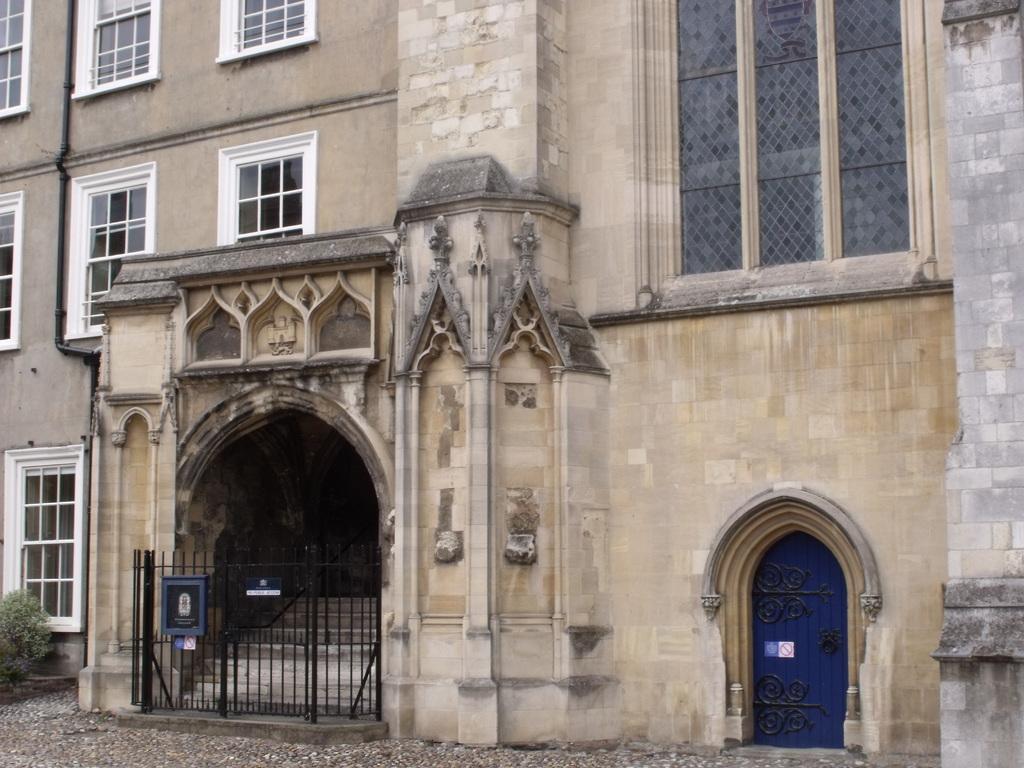How would you summarize this image in a sentence or two? In this picture, we see a building. It has windows and a blue door. At the bottom, we see the stones. Beside that, we see a black railing. Behind that, we see the staircase. On the left side, we see a tree or a plant. 